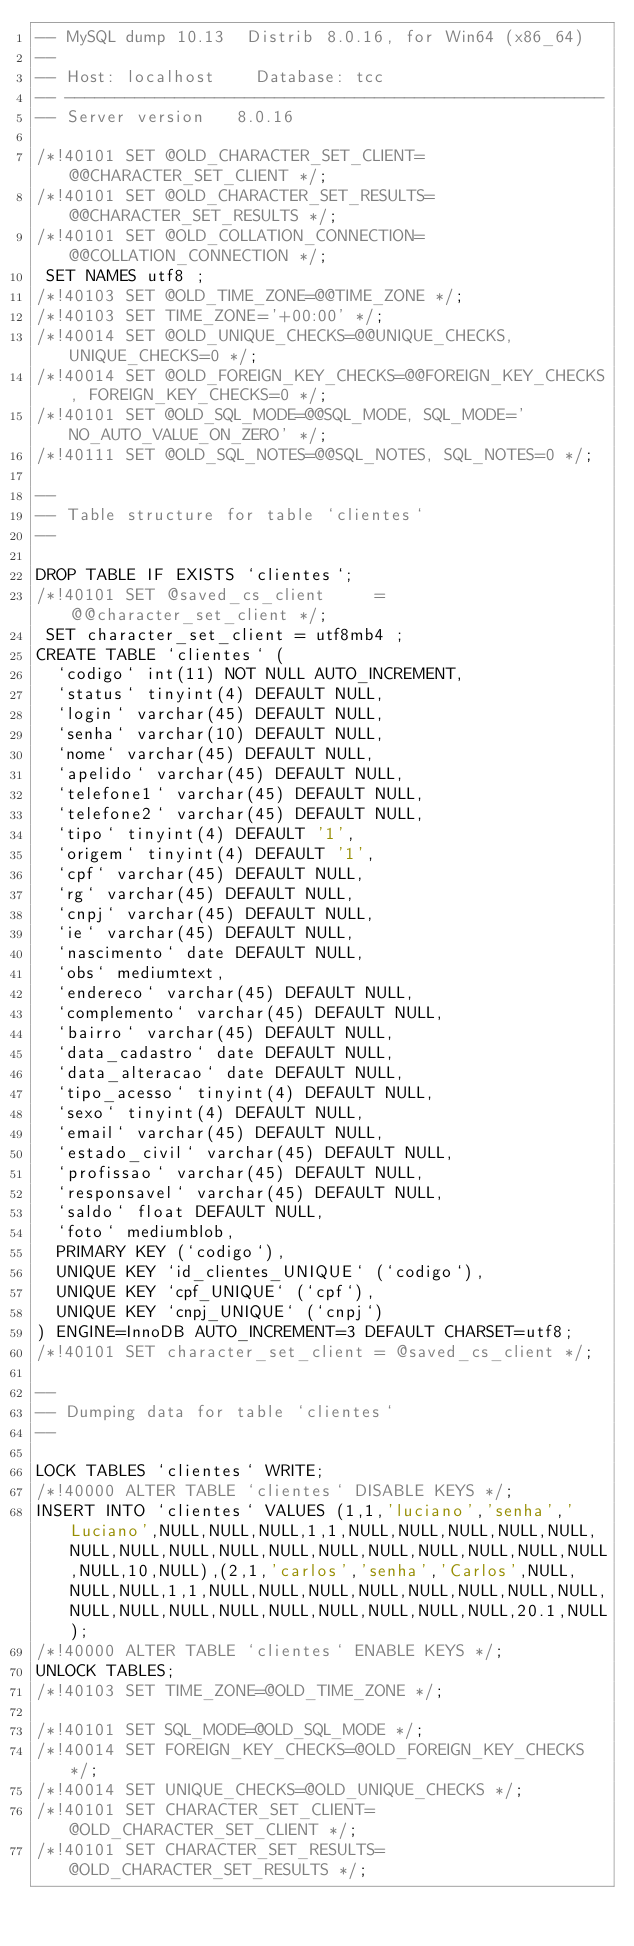<code> <loc_0><loc_0><loc_500><loc_500><_SQL_>-- MySQL dump 10.13  Distrib 8.0.16, for Win64 (x86_64)
--
-- Host: localhost    Database: tcc
-- ------------------------------------------------------
-- Server version	8.0.16

/*!40101 SET @OLD_CHARACTER_SET_CLIENT=@@CHARACTER_SET_CLIENT */;
/*!40101 SET @OLD_CHARACTER_SET_RESULTS=@@CHARACTER_SET_RESULTS */;
/*!40101 SET @OLD_COLLATION_CONNECTION=@@COLLATION_CONNECTION */;
 SET NAMES utf8 ;
/*!40103 SET @OLD_TIME_ZONE=@@TIME_ZONE */;
/*!40103 SET TIME_ZONE='+00:00' */;
/*!40014 SET @OLD_UNIQUE_CHECKS=@@UNIQUE_CHECKS, UNIQUE_CHECKS=0 */;
/*!40014 SET @OLD_FOREIGN_KEY_CHECKS=@@FOREIGN_KEY_CHECKS, FOREIGN_KEY_CHECKS=0 */;
/*!40101 SET @OLD_SQL_MODE=@@SQL_MODE, SQL_MODE='NO_AUTO_VALUE_ON_ZERO' */;
/*!40111 SET @OLD_SQL_NOTES=@@SQL_NOTES, SQL_NOTES=0 */;

--
-- Table structure for table `clientes`
--

DROP TABLE IF EXISTS `clientes`;
/*!40101 SET @saved_cs_client     = @@character_set_client */;
 SET character_set_client = utf8mb4 ;
CREATE TABLE `clientes` (
  `codigo` int(11) NOT NULL AUTO_INCREMENT,
  `status` tinyint(4) DEFAULT NULL,
  `login` varchar(45) DEFAULT NULL,
  `senha` varchar(10) DEFAULT NULL,
  `nome` varchar(45) DEFAULT NULL,
  `apelido` varchar(45) DEFAULT NULL,
  `telefone1` varchar(45) DEFAULT NULL,
  `telefone2` varchar(45) DEFAULT NULL,
  `tipo` tinyint(4) DEFAULT '1',
  `origem` tinyint(4) DEFAULT '1',
  `cpf` varchar(45) DEFAULT NULL,
  `rg` varchar(45) DEFAULT NULL,
  `cnpj` varchar(45) DEFAULT NULL,
  `ie` varchar(45) DEFAULT NULL,
  `nascimento` date DEFAULT NULL,
  `obs` mediumtext,
  `endereco` varchar(45) DEFAULT NULL,
  `complemento` varchar(45) DEFAULT NULL,
  `bairro` varchar(45) DEFAULT NULL,
  `data_cadastro` date DEFAULT NULL,
  `data_alteracao` date DEFAULT NULL,
  `tipo_acesso` tinyint(4) DEFAULT NULL,
  `sexo` tinyint(4) DEFAULT NULL,
  `email` varchar(45) DEFAULT NULL,
  `estado_civil` varchar(45) DEFAULT NULL,
  `profissao` varchar(45) DEFAULT NULL,
  `responsavel` varchar(45) DEFAULT NULL,
  `saldo` float DEFAULT NULL,
  `foto` mediumblob,
  PRIMARY KEY (`codigo`),
  UNIQUE KEY `id_clientes_UNIQUE` (`codigo`),
  UNIQUE KEY `cpf_UNIQUE` (`cpf`),
  UNIQUE KEY `cnpj_UNIQUE` (`cnpj`)
) ENGINE=InnoDB AUTO_INCREMENT=3 DEFAULT CHARSET=utf8;
/*!40101 SET character_set_client = @saved_cs_client */;

--
-- Dumping data for table `clientes`
--

LOCK TABLES `clientes` WRITE;
/*!40000 ALTER TABLE `clientes` DISABLE KEYS */;
INSERT INTO `clientes` VALUES (1,1,'luciano','senha','Luciano',NULL,NULL,NULL,1,1,NULL,NULL,NULL,NULL,NULL,NULL,NULL,NULL,NULL,NULL,NULL,NULL,NULL,NULL,NULL,NULL,NULL,10,NULL),(2,1,'carlos','senha','Carlos',NULL,NULL,NULL,1,1,NULL,NULL,NULL,NULL,NULL,NULL,NULL,NULL,NULL,NULL,NULL,NULL,NULL,NULL,NULL,NULL,NULL,20.1,NULL);
/*!40000 ALTER TABLE `clientes` ENABLE KEYS */;
UNLOCK TABLES;
/*!40103 SET TIME_ZONE=@OLD_TIME_ZONE */;

/*!40101 SET SQL_MODE=@OLD_SQL_MODE */;
/*!40014 SET FOREIGN_KEY_CHECKS=@OLD_FOREIGN_KEY_CHECKS */;
/*!40014 SET UNIQUE_CHECKS=@OLD_UNIQUE_CHECKS */;
/*!40101 SET CHARACTER_SET_CLIENT=@OLD_CHARACTER_SET_CLIENT */;
/*!40101 SET CHARACTER_SET_RESULTS=@OLD_CHARACTER_SET_RESULTS */;</code> 